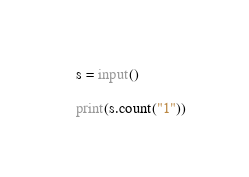<code> <loc_0><loc_0><loc_500><loc_500><_Python_>s = input()

print(s.count("1"))</code> 